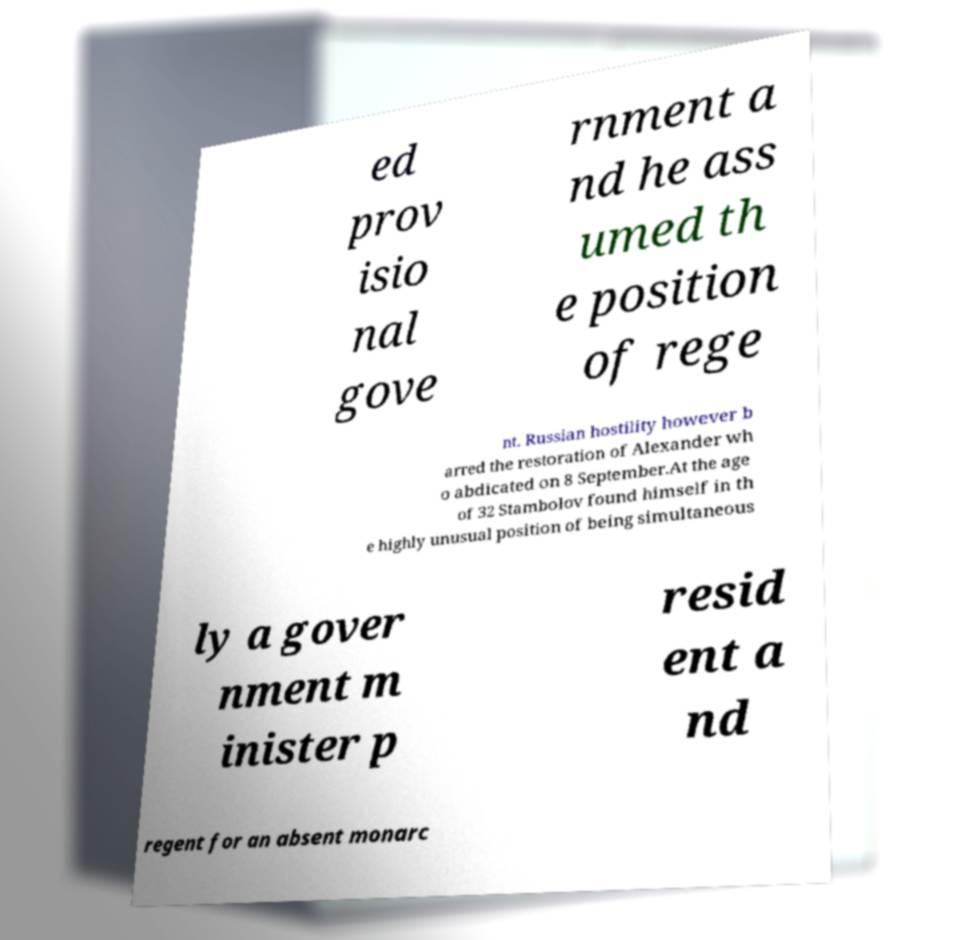Could you extract and type out the text from this image? ed prov isio nal gove rnment a nd he ass umed th e position of rege nt. Russian hostility however b arred the restoration of Alexander wh o abdicated on 8 September.At the age of 32 Stambolov found himself in th e highly unusual position of being simultaneous ly a gover nment m inister p resid ent a nd regent for an absent monarc 